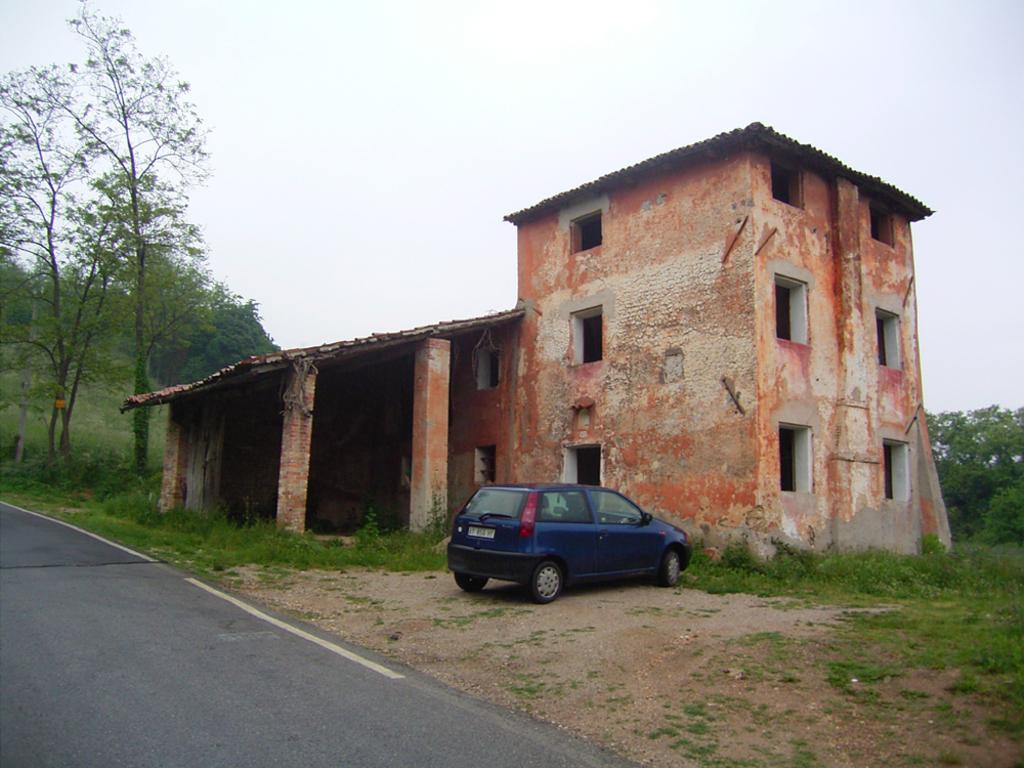What is located in the foreground of the image? There is a vehicle, a building, and a shed in the foreground of the image. Can you describe the structures in the foreground? There is a vehicle, a building, and a shed in the foreground of the image. What can be seen in the background of the image? There are trees and the sky visible in the background of the image. What type of list can be seen hanging from the shed in the image? There is no list present in the image, and therefore no such item can be observed hanging from the shed. 